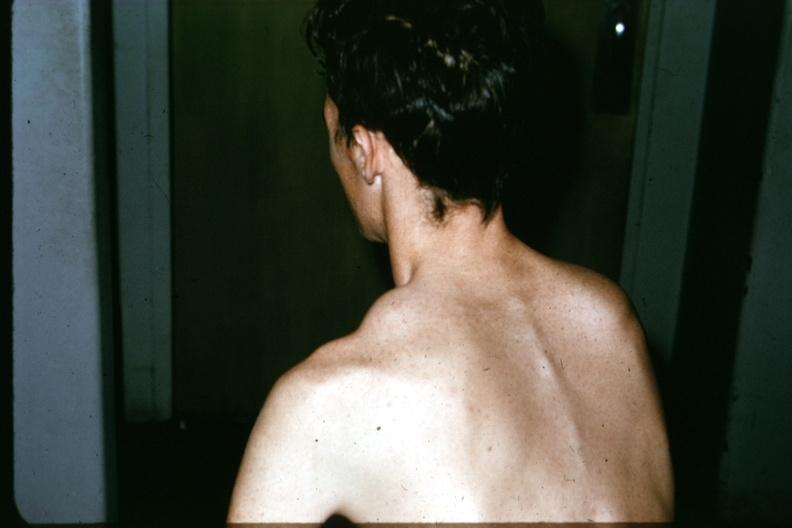when does this image show patient?
Answer the question using a single word or phrase. Before surgery lesion in clavicle 